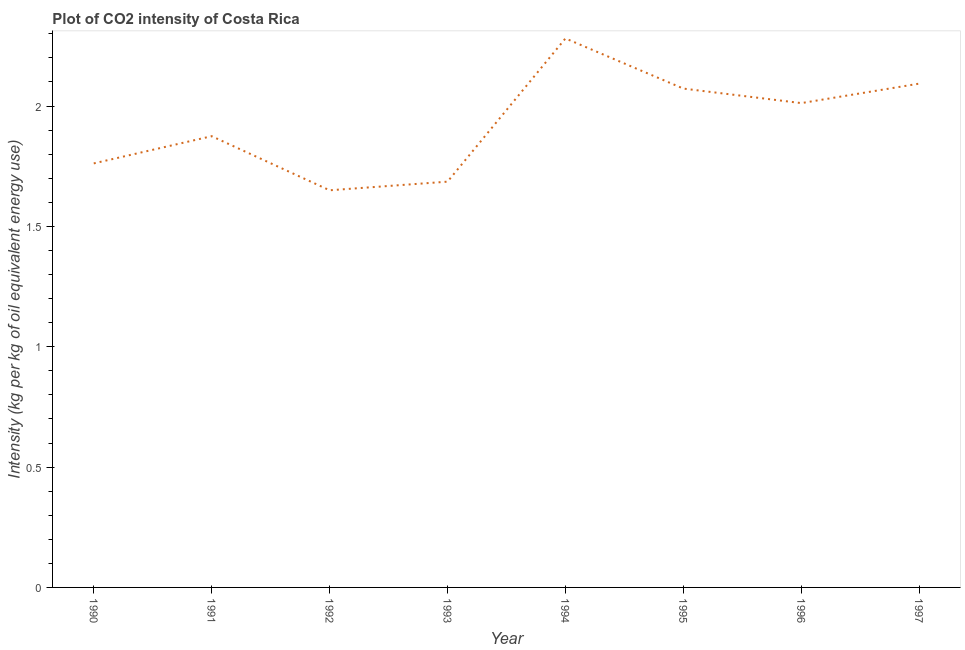What is the co2 intensity in 1991?
Offer a terse response. 1.87. Across all years, what is the maximum co2 intensity?
Provide a succinct answer. 2.28. Across all years, what is the minimum co2 intensity?
Your answer should be very brief. 1.65. In which year was the co2 intensity maximum?
Offer a very short reply. 1994. What is the sum of the co2 intensity?
Ensure brevity in your answer.  15.43. What is the difference between the co2 intensity in 1990 and 1994?
Ensure brevity in your answer.  -0.52. What is the average co2 intensity per year?
Offer a terse response. 1.93. What is the median co2 intensity?
Your answer should be compact. 1.94. Do a majority of the years between 1990 and 1993 (inclusive) have co2 intensity greater than 1.5 kg?
Keep it short and to the point. Yes. What is the ratio of the co2 intensity in 1991 to that in 1993?
Provide a short and direct response. 1.11. Is the co2 intensity in 1994 less than that in 1995?
Keep it short and to the point. No. What is the difference between the highest and the second highest co2 intensity?
Give a very brief answer. 0.19. What is the difference between the highest and the lowest co2 intensity?
Keep it short and to the point. 0.63. In how many years, is the co2 intensity greater than the average co2 intensity taken over all years?
Offer a terse response. 4. Does the co2 intensity monotonically increase over the years?
Provide a succinct answer. No. How many years are there in the graph?
Offer a terse response. 8. What is the title of the graph?
Ensure brevity in your answer.  Plot of CO2 intensity of Costa Rica. What is the label or title of the Y-axis?
Offer a terse response. Intensity (kg per kg of oil equivalent energy use). What is the Intensity (kg per kg of oil equivalent energy use) in 1990?
Provide a short and direct response. 1.76. What is the Intensity (kg per kg of oil equivalent energy use) of 1991?
Offer a very short reply. 1.87. What is the Intensity (kg per kg of oil equivalent energy use) of 1992?
Your response must be concise. 1.65. What is the Intensity (kg per kg of oil equivalent energy use) in 1993?
Give a very brief answer. 1.69. What is the Intensity (kg per kg of oil equivalent energy use) in 1994?
Provide a short and direct response. 2.28. What is the Intensity (kg per kg of oil equivalent energy use) in 1995?
Provide a short and direct response. 2.07. What is the Intensity (kg per kg of oil equivalent energy use) of 1996?
Give a very brief answer. 2.01. What is the Intensity (kg per kg of oil equivalent energy use) in 1997?
Your response must be concise. 2.09. What is the difference between the Intensity (kg per kg of oil equivalent energy use) in 1990 and 1991?
Provide a short and direct response. -0.11. What is the difference between the Intensity (kg per kg of oil equivalent energy use) in 1990 and 1992?
Give a very brief answer. 0.11. What is the difference between the Intensity (kg per kg of oil equivalent energy use) in 1990 and 1993?
Give a very brief answer. 0.08. What is the difference between the Intensity (kg per kg of oil equivalent energy use) in 1990 and 1994?
Keep it short and to the point. -0.52. What is the difference between the Intensity (kg per kg of oil equivalent energy use) in 1990 and 1995?
Provide a succinct answer. -0.31. What is the difference between the Intensity (kg per kg of oil equivalent energy use) in 1990 and 1996?
Make the answer very short. -0.25. What is the difference between the Intensity (kg per kg of oil equivalent energy use) in 1990 and 1997?
Provide a short and direct response. -0.33. What is the difference between the Intensity (kg per kg of oil equivalent energy use) in 1991 and 1992?
Offer a very short reply. 0.22. What is the difference between the Intensity (kg per kg of oil equivalent energy use) in 1991 and 1993?
Give a very brief answer. 0.19. What is the difference between the Intensity (kg per kg of oil equivalent energy use) in 1991 and 1994?
Offer a terse response. -0.41. What is the difference between the Intensity (kg per kg of oil equivalent energy use) in 1991 and 1995?
Your answer should be very brief. -0.2. What is the difference between the Intensity (kg per kg of oil equivalent energy use) in 1991 and 1996?
Offer a very short reply. -0.14. What is the difference between the Intensity (kg per kg of oil equivalent energy use) in 1991 and 1997?
Your response must be concise. -0.22. What is the difference between the Intensity (kg per kg of oil equivalent energy use) in 1992 and 1993?
Your answer should be compact. -0.04. What is the difference between the Intensity (kg per kg of oil equivalent energy use) in 1992 and 1994?
Offer a terse response. -0.63. What is the difference between the Intensity (kg per kg of oil equivalent energy use) in 1992 and 1995?
Your answer should be very brief. -0.42. What is the difference between the Intensity (kg per kg of oil equivalent energy use) in 1992 and 1996?
Offer a terse response. -0.36. What is the difference between the Intensity (kg per kg of oil equivalent energy use) in 1992 and 1997?
Provide a succinct answer. -0.44. What is the difference between the Intensity (kg per kg of oil equivalent energy use) in 1993 and 1994?
Your response must be concise. -0.6. What is the difference between the Intensity (kg per kg of oil equivalent energy use) in 1993 and 1995?
Your response must be concise. -0.39. What is the difference between the Intensity (kg per kg of oil equivalent energy use) in 1993 and 1996?
Your answer should be very brief. -0.33. What is the difference between the Intensity (kg per kg of oil equivalent energy use) in 1993 and 1997?
Make the answer very short. -0.41. What is the difference between the Intensity (kg per kg of oil equivalent energy use) in 1994 and 1995?
Your answer should be compact. 0.21. What is the difference between the Intensity (kg per kg of oil equivalent energy use) in 1994 and 1996?
Your response must be concise. 0.27. What is the difference between the Intensity (kg per kg of oil equivalent energy use) in 1994 and 1997?
Offer a very short reply. 0.19. What is the difference between the Intensity (kg per kg of oil equivalent energy use) in 1995 and 1996?
Your answer should be very brief. 0.06. What is the difference between the Intensity (kg per kg of oil equivalent energy use) in 1995 and 1997?
Your answer should be compact. -0.02. What is the difference between the Intensity (kg per kg of oil equivalent energy use) in 1996 and 1997?
Provide a succinct answer. -0.08. What is the ratio of the Intensity (kg per kg of oil equivalent energy use) in 1990 to that in 1992?
Keep it short and to the point. 1.07. What is the ratio of the Intensity (kg per kg of oil equivalent energy use) in 1990 to that in 1993?
Your answer should be very brief. 1.04. What is the ratio of the Intensity (kg per kg of oil equivalent energy use) in 1990 to that in 1994?
Keep it short and to the point. 0.77. What is the ratio of the Intensity (kg per kg of oil equivalent energy use) in 1990 to that in 1996?
Your answer should be compact. 0.88. What is the ratio of the Intensity (kg per kg of oil equivalent energy use) in 1990 to that in 1997?
Make the answer very short. 0.84. What is the ratio of the Intensity (kg per kg of oil equivalent energy use) in 1991 to that in 1992?
Give a very brief answer. 1.14. What is the ratio of the Intensity (kg per kg of oil equivalent energy use) in 1991 to that in 1993?
Your answer should be very brief. 1.11. What is the ratio of the Intensity (kg per kg of oil equivalent energy use) in 1991 to that in 1994?
Provide a succinct answer. 0.82. What is the ratio of the Intensity (kg per kg of oil equivalent energy use) in 1991 to that in 1995?
Provide a succinct answer. 0.91. What is the ratio of the Intensity (kg per kg of oil equivalent energy use) in 1991 to that in 1996?
Give a very brief answer. 0.93. What is the ratio of the Intensity (kg per kg of oil equivalent energy use) in 1991 to that in 1997?
Your response must be concise. 0.9. What is the ratio of the Intensity (kg per kg of oil equivalent energy use) in 1992 to that in 1993?
Ensure brevity in your answer.  0.98. What is the ratio of the Intensity (kg per kg of oil equivalent energy use) in 1992 to that in 1994?
Your response must be concise. 0.72. What is the ratio of the Intensity (kg per kg of oil equivalent energy use) in 1992 to that in 1995?
Ensure brevity in your answer.  0.8. What is the ratio of the Intensity (kg per kg of oil equivalent energy use) in 1992 to that in 1996?
Give a very brief answer. 0.82. What is the ratio of the Intensity (kg per kg of oil equivalent energy use) in 1992 to that in 1997?
Your answer should be very brief. 0.79. What is the ratio of the Intensity (kg per kg of oil equivalent energy use) in 1993 to that in 1994?
Offer a terse response. 0.74. What is the ratio of the Intensity (kg per kg of oil equivalent energy use) in 1993 to that in 1995?
Provide a short and direct response. 0.81. What is the ratio of the Intensity (kg per kg of oil equivalent energy use) in 1993 to that in 1996?
Your response must be concise. 0.84. What is the ratio of the Intensity (kg per kg of oil equivalent energy use) in 1993 to that in 1997?
Your answer should be very brief. 0.81. What is the ratio of the Intensity (kg per kg of oil equivalent energy use) in 1994 to that in 1995?
Ensure brevity in your answer.  1.1. What is the ratio of the Intensity (kg per kg of oil equivalent energy use) in 1994 to that in 1996?
Your answer should be very brief. 1.13. What is the ratio of the Intensity (kg per kg of oil equivalent energy use) in 1994 to that in 1997?
Make the answer very short. 1.09. What is the ratio of the Intensity (kg per kg of oil equivalent energy use) in 1996 to that in 1997?
Your answer should be compact. 0.96. 